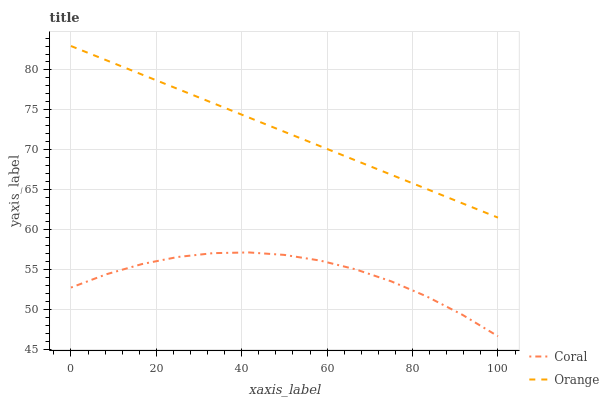Does Coral have the minimum area under the curve?
Answer yes or no. Yes. Does Orange have the maximum area under the curve?
Answer yes or no. Yes. Does Coral have the maximum area under the curve?
Answer yes or no. No. Is Orange the smoothest?
Answer yes or no. Yes. Is Coral the roughest?
Answer yes or no. Yes. Is Coral the smoothest?
Answer yes or no. No. Does Coral have the lowest value?
Answer yes or no. Yes. Does Orange have the highest value?
Answer yes or no. Yes. Does Coral have the highest value?
Answer yes or no. No. Is Coral less than Orange?
Answer yes or no. Yes. Is Orange greater than Coral?
Answer yes or no. Yes. Does Coral intersect Orange?
Answer yes or no. No. 